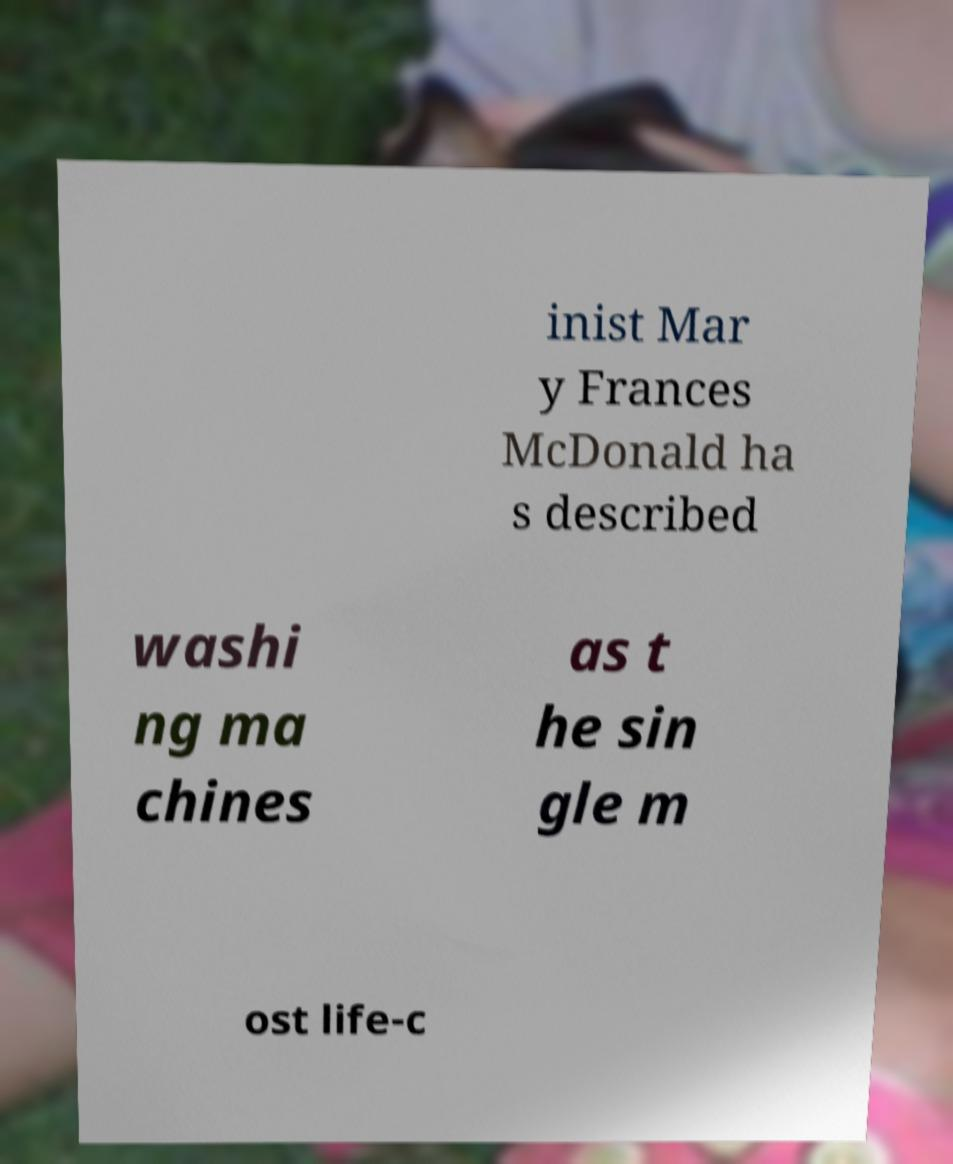There's text embedded in this image that I need extracted. Can you transcribe it verbatim? inist Mar y Frances McDonald ha s described washi ng ma chines as t he sin gle m ost life-c 